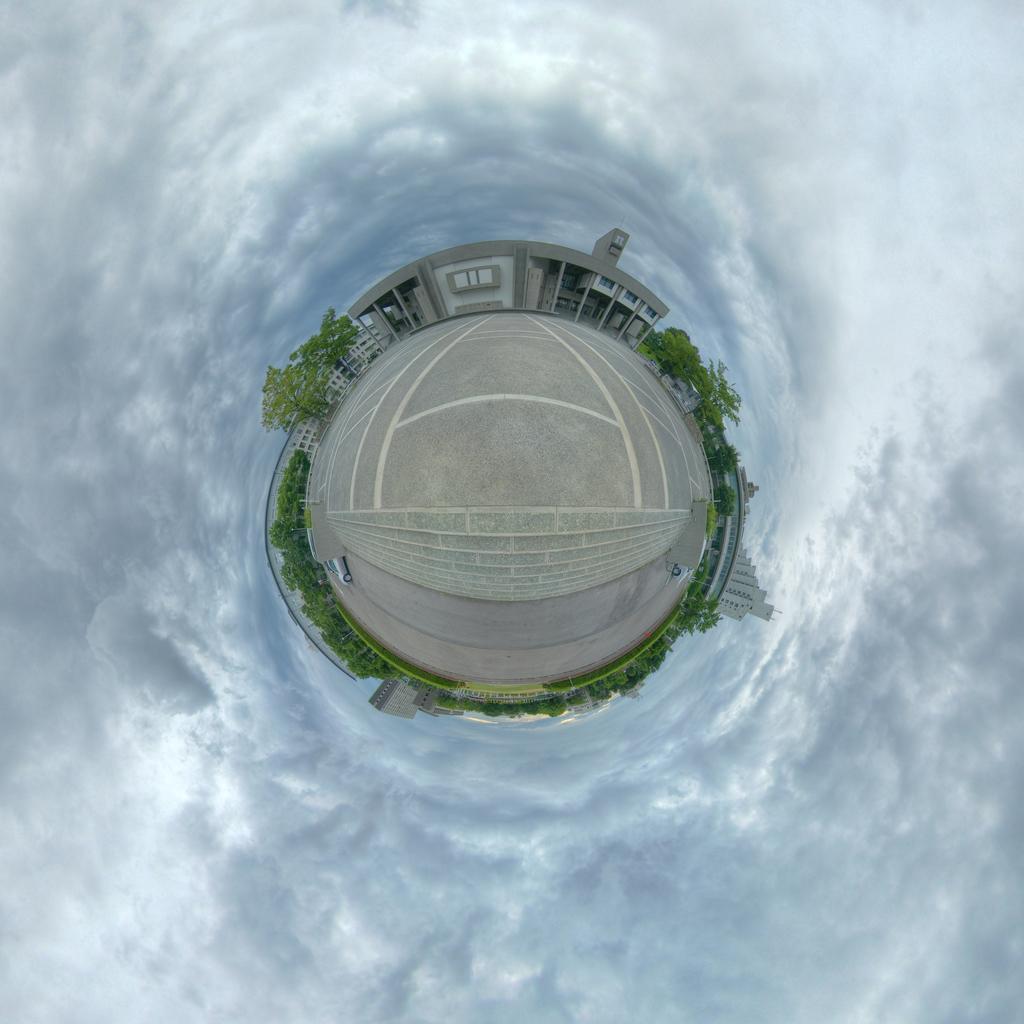How would you summarize this image in a sentence or two? This image is an animated image. In the middle there are buildings, trees, car and road. In the background there are sky and clouds. 